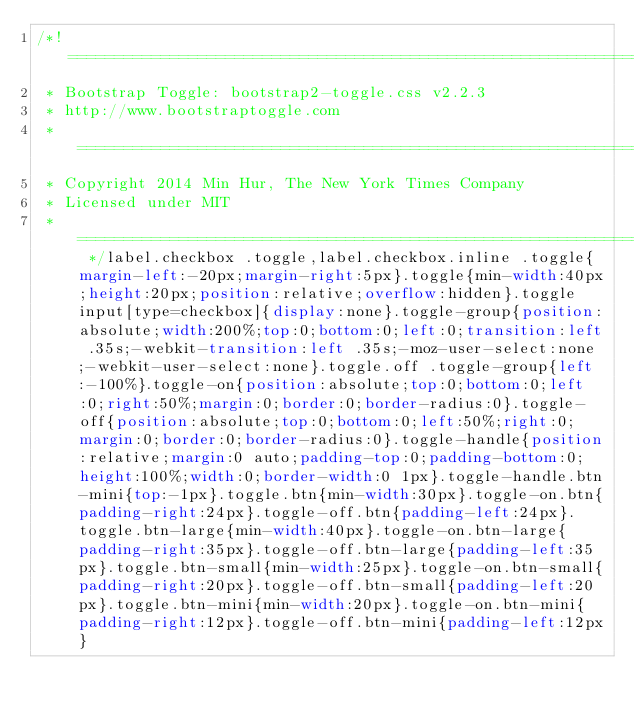Convert code to text. <code><loc_0><loc_0><loc_500><loc_500><_CSS_>/*! ========================================================================
 * Bootstrap Toggle: bootstrap2-toggle.css v2.2.3
 * http://www.bootstraptoggle.com
 * ========================================================================
 * Copyright 2014 Min Hur, The New York Times Company
 * Licensed under MIT
 * ======================================================================== */label.checkbox .toggle,label.checkbox.inline .toggle{margin-left:-20px;margin-right:5px}.toggle{min-width:40px;height:20px;position:relative;overflow:hidden}.toggle input[type=checkbox]{display:none}.toggle-group{position:absolute;width:200%;top:0;bottom:0;left:0;transition:left .35s;-webkit-transition:left .35s;-moz-user-select:none;-webkit-user-select:none}.toggle.off .toggle-group{left:-100%}.toggle-on{position:absolute;top:0;bottom:0;left:0;right:50%;margin:0;border:0;border-radius:0}.toggle-off{position:absolute;top:0;bottom:0;left:50%;right:0;margin:0;border:0;border-radius:0}.toggle-handle{position:relative;margin:0 auto;padding-top:0;padding-bottom:0;height:100%;width:0;border-width:0 1px}.toggle-handle.btn-mini{top:-1px}.toggle.btn{min-width:30px}.toggle-on.btn{padding-right:24px}.toggle-off.btn{padding-left:24px}.toggle.btn-large{min-width:40px}.toggle-on.btn-large{padding-right:35px}.toggle-off.btn-large{padding-left:35px}.toggle.btn-small{min-width:25px}.toggle-on.btn-small{padding-right:20px}.toggle-off.btn-small{padding-left:20px}.toggle.btn-mini{min-width:20px}.toggle-on.btn-mini{padding-right:12px}.toggle-off.btn-mini{padding-left:12px}</code> 